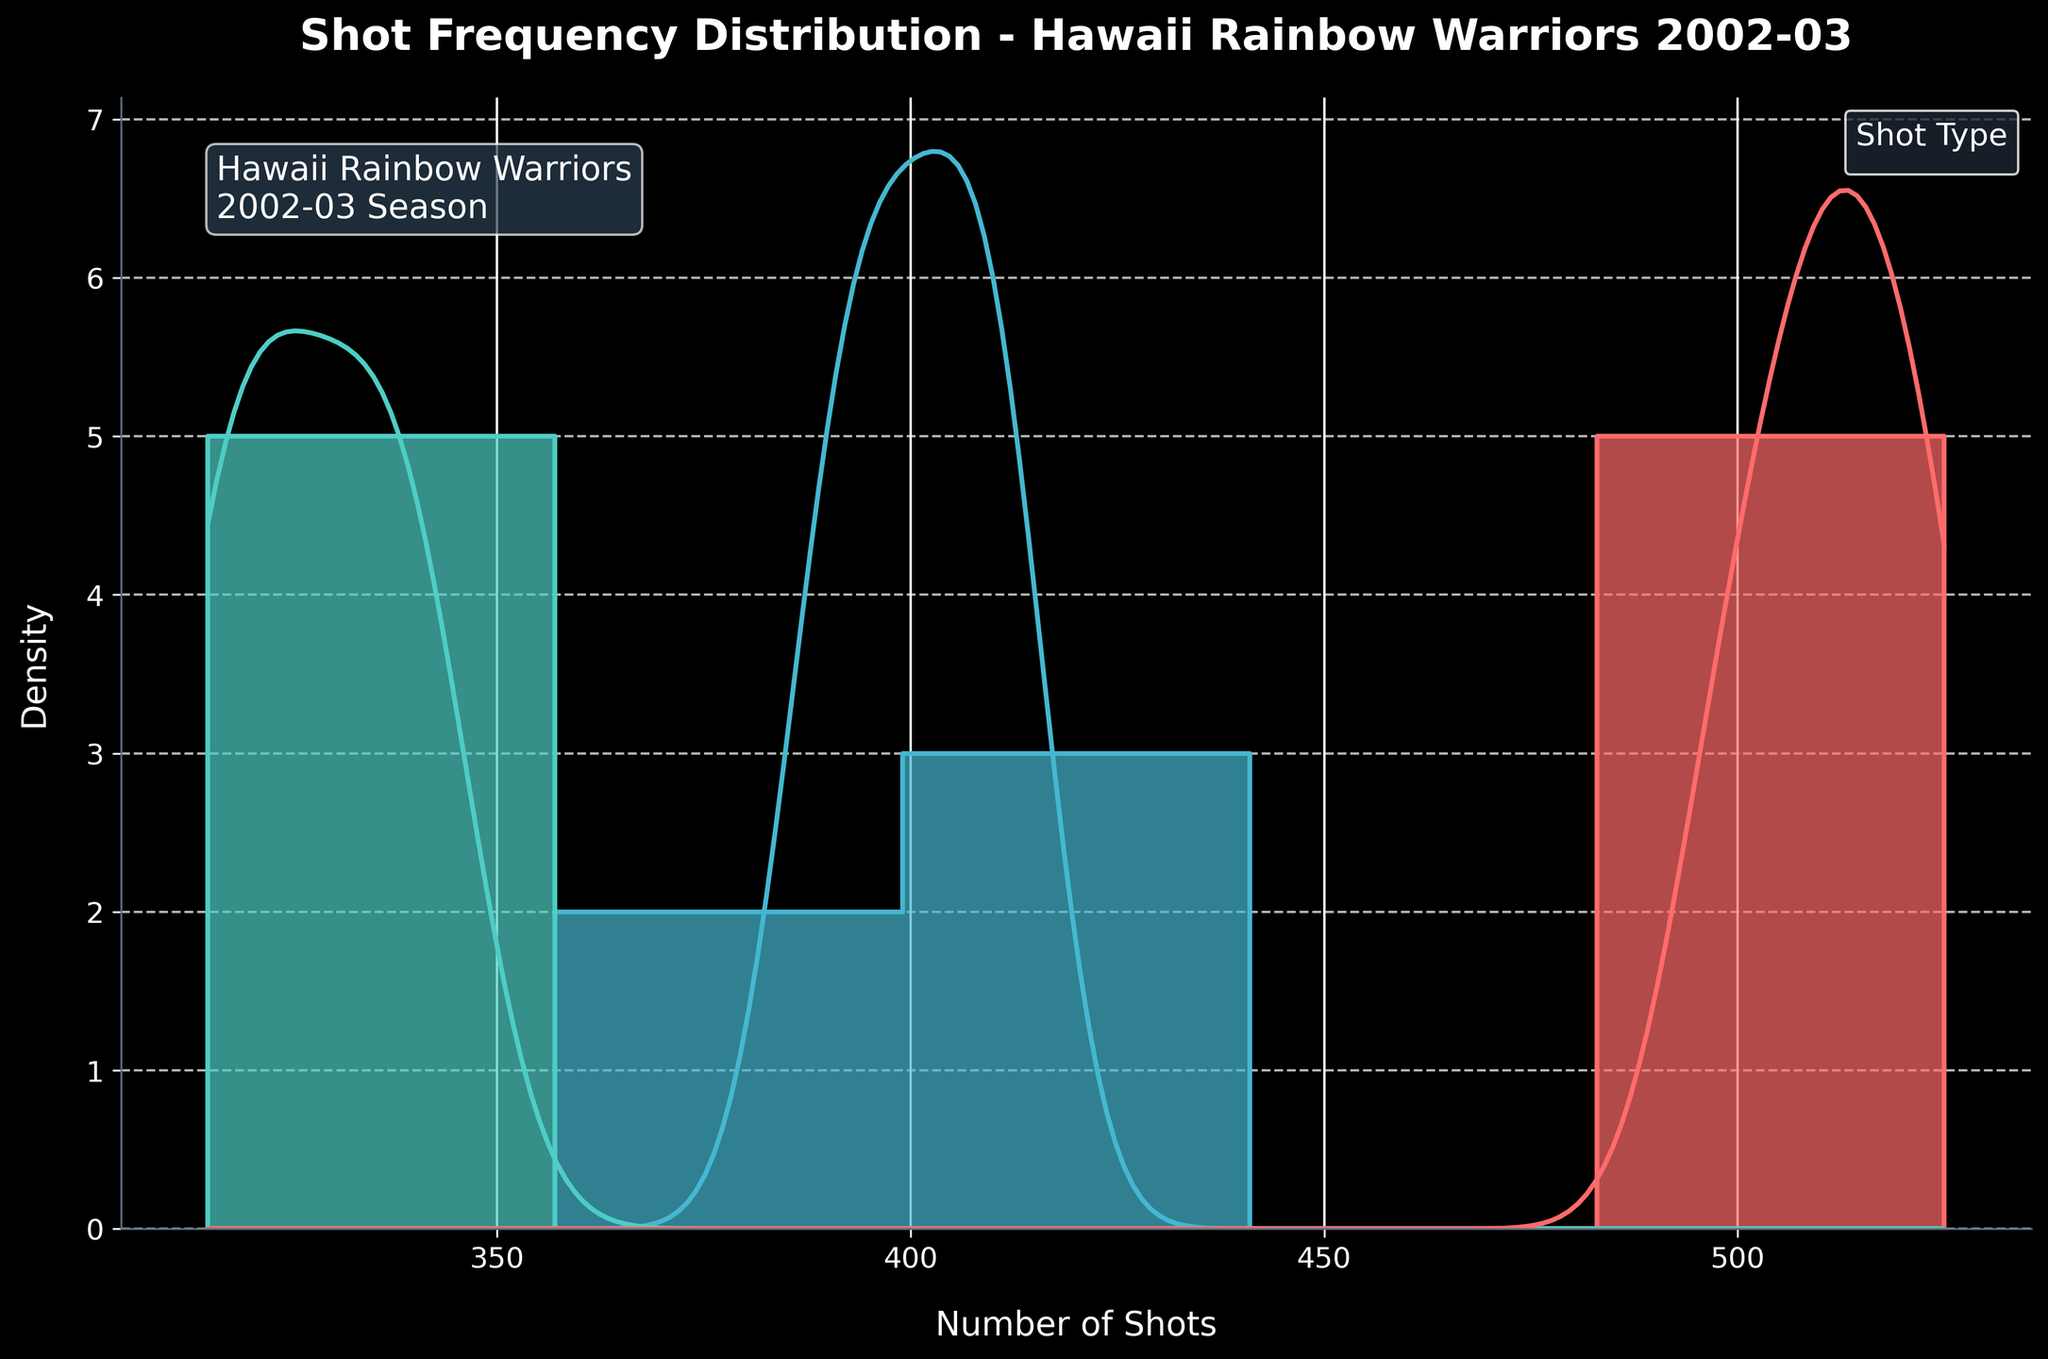what's the title of the plot? The title of a plot is usually located at the top and provides a brief description of the figure. In this case, the title clearly states, "Shot Frequency Distribution - Hawaii Rainbow Warriors 2002-03."
Answer: Shot Frequency Distribution - Hawaii Rainbow Warriors 2002-03 which axis represents the number of shots? The x-axis typically represents the numerical values in a histogram. Here, the x-axis is labeled "Number of Shots."
Answer: x-axis how many times do free throws peak on the density curve? To find the peaks on the density curve for free throws, look at where the KDE (Kernel Density Estimate) curve for free throws reaches its highest points. The color associated with free throws should be consistent throughout the plot, typically aligning with the color legend. Since we are not looking at the figure directly, count the distinct high points along the free throw curve.
Answer: 2 times which shot type has the highest frequency range? By observing the KDE curves and histograms, the shot type that extends furthest along the x-axis has the highest frequency range. Assess the span of each type's distribution on the figure.
Answer: 2-pointers which shot types show overlapping ranges of frequencies? Overlapping ranges can be identified by noticing where the KDE curves or histogram bars for different shot types overlap on the x-axis. Look for regions where multiple colors are visible or where multiple curves intersect.
Answer: 2-pointers and Free Throws what is the average number of shots taken for 3-pointers across the data provided? Calculate the average by summing up the frequencies for 3-pointers and dividing by the number of data points. The frequencies for 3-pointers are 328, 342, 315, 336, and 320. Total is 328 + 342 + 315 + 336 + 320 = 1641. Divide by 5 data points: 1641/5 = 328.2
Answer: 328.2 which shot type has the lower peak density, 2-pointers or 3-pointers? Compare the heights of the KDE peaks for the 2-pointers and 3-pointers. The one with the lower peak density on the y-axis is the answer.
Answer: 3-pointers if the plot indicates a grid pattern, which axis has the grid lines visible? The description mentions a grid applied to the y-axis using dashed lines. We can conclude that the y-axis has grid lines visible.
Answer: y-axis do free throws have more variation in frequency compared to 2-pointers? Variation can be interpreted by the spread of the KDE curve or histogram along the x-axis. A wider spread indicates more variation. Compare the spreads of the KDE curves of free throws and 2-pointers.
Answer: No how many total data points per shot type are used in generating the plot? Count the number of data points provided for each shot type. The dataset has 5 points each for 2-pointers, 3-pointers, and free throws.
Answer: 5 per shot type 